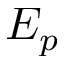Convert formula to latex. <formula><loc_0><loc_0><loc_500><loc_500>E _ { p }</formula> 